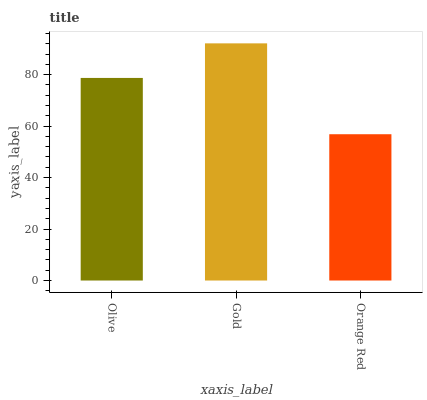Is Orange Red the minimum?
Answer yes or no. Yes. Is Gold the maximum?
Answer yes or no. Yes. Is Gold the minimum?
Answer yes or no. No. Is Orange Red the maximum?
Answer yes or no. No. Is Gold greater than Orange Red?
Answer yes or no. Yes. Is Orange Red less than Gold?
Answer yes or no. Yes. Is Orange Red greater than Gold?
Answer yes or no. No. Is Gold less than Orange Red?
Answer yes or no. No. Is Olive the high median?
Answer yes or no. Yes. Is Olive the low median?
Answer yes or no. Yes. Is Gold the high median?
Answer yes or no. No. Is Orange Red the low median?
Answer yes or no. No. 